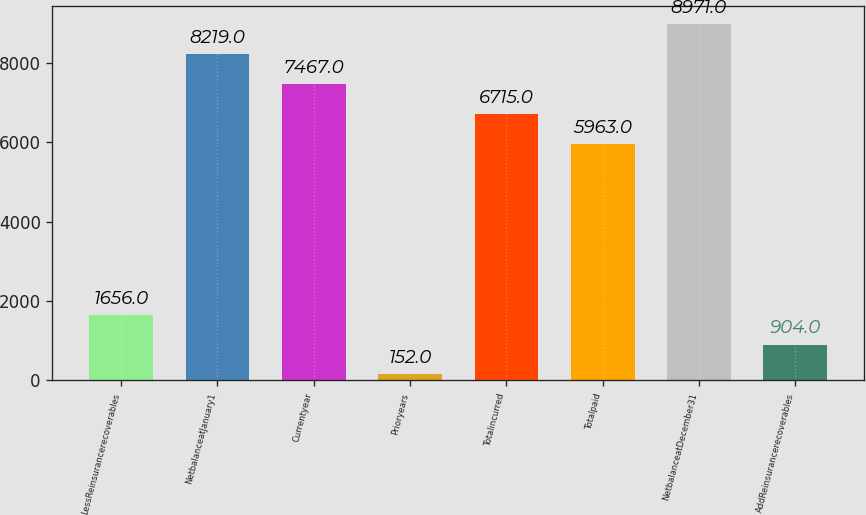<chart> <loc_0><loc_0><loc_500><loc_500><bar_chart><fcel>LessReinsurancerecoverables<fcel>NetbalanceatJanuary1<fcel>Currentyear<fcel>Prioryears<fcel>Totalincurred<fcel>Totalpaid<fcel>NetbalanceatDecember31<fcel>AddReinsurancerecoverables<nl><fcel>1656<fcel>8219<fcel>7467<fcel>152<fcel>6715<fcel>5963<fcel>8971<fcel>904<nl></chart> 